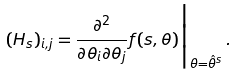<formula> <loc_0><loc_0><loc_500><loc_500>( H _ { s } ) _ { i , j } = \frac { \partial ^ { 2 } } { \partial \theta _ { i } \partial \theta _ { j } } f ( s , \theta ) \Big | _ { \theta = \hat { \theta } ^ { s } } \, .</formula> 